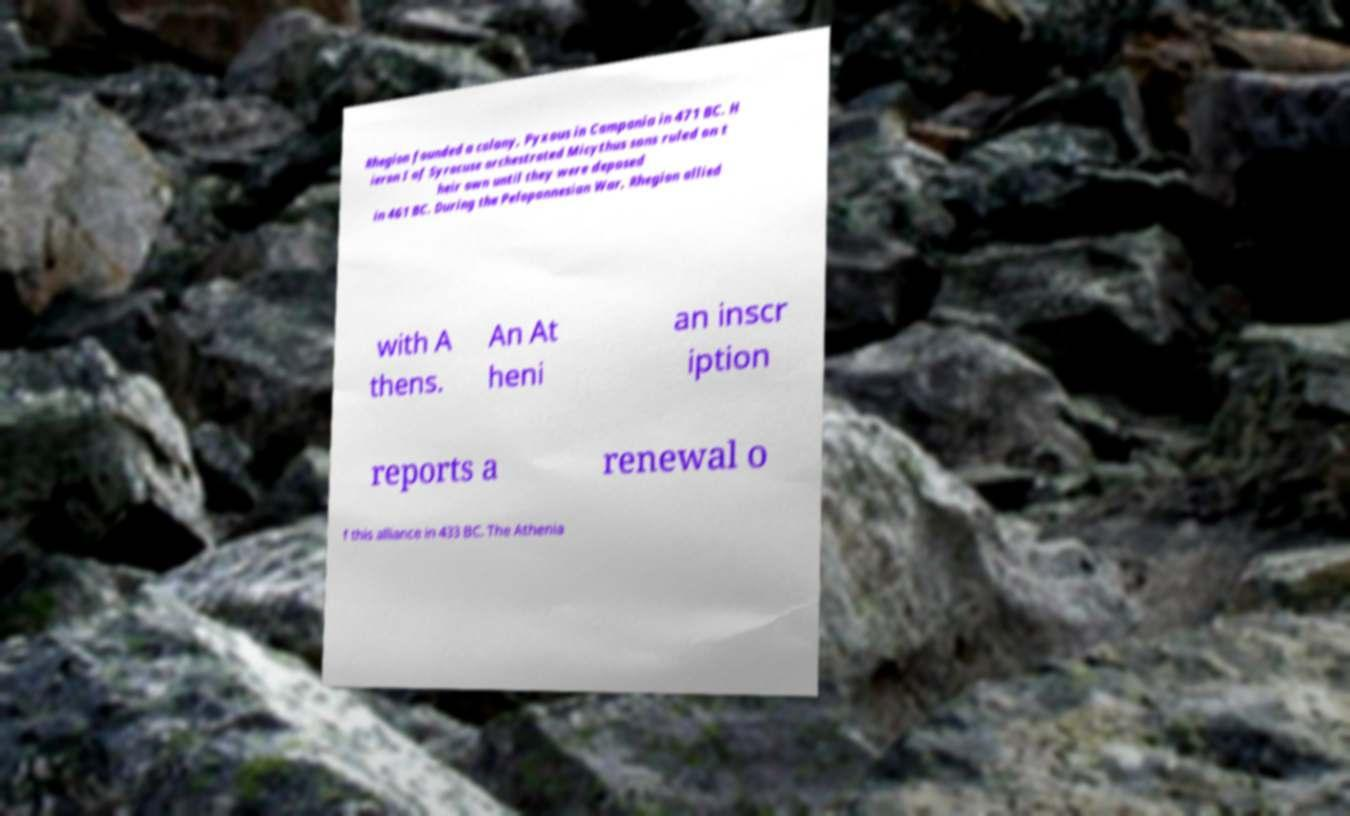What messages or text are displayed in this image? I need them in a readable, typed format. Rhegion founded a colony, Pyxous in Campania in 471 BC. H ieron I of Syracuse orchestrated Micythus sons ruled on t heir own until they were deposed in 461 BC. During the Peloponnesian War, Rhegion allied with A thens. An At heni an inscr iption reports a renewal o f this alliance in 433 BC. The Athenia 